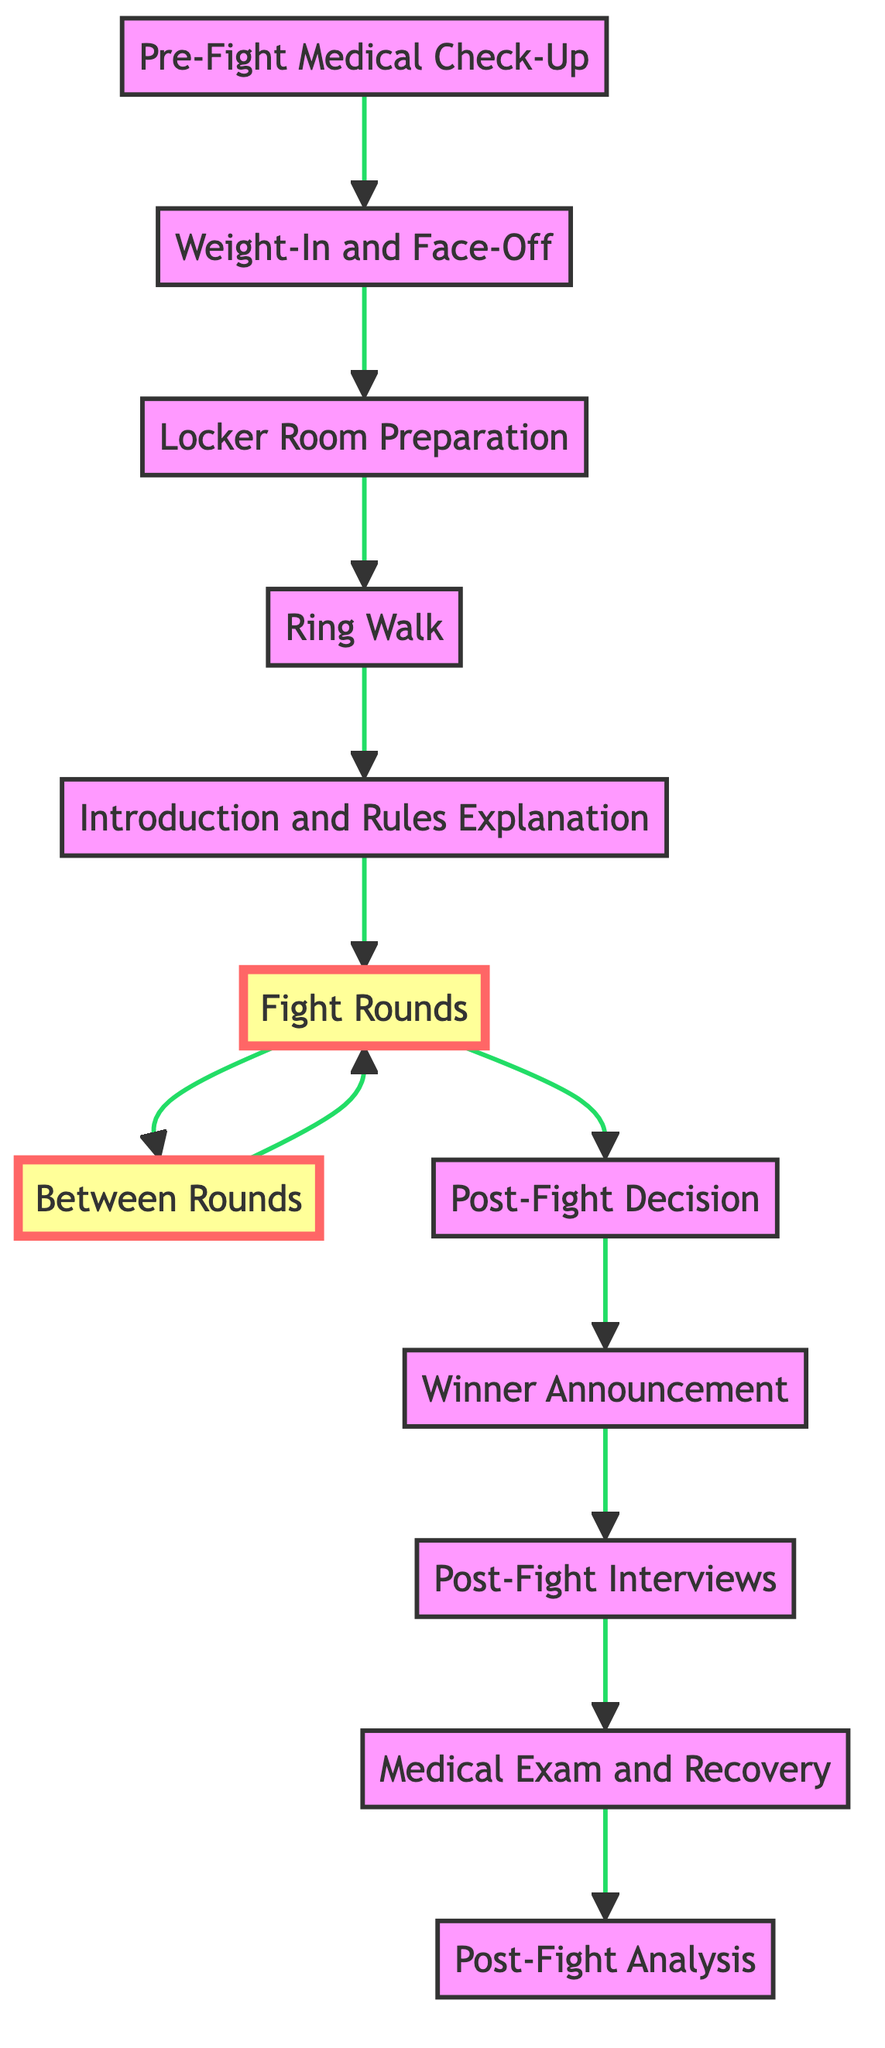What is the first step in the boxing match flow? The first step in the diagram is the "Pre-Fight Medical Check-Up," indicating that fighters start with medical examinations to ensure their fitness for the match.
Answer: Pre-Fight Medical Check-Up How many fight rounds are typically in a professional boxing match? According to the information in the diagram, a professional boxing match usually consists of 12 rounds, each lasting for 3 minutes.
Answer: 12 What happens after the "Fight Rounds"? After the "Fight Rounds," the next step described in the diagram is the "Post-Fight Decision," where judges assess the fight for a winner.
Answer: Post-Fight Decision What process occurs between each fight round? Between each fight round, fighters return to their corners for a one-minute rest where they receive advice and treatment from their trainers and cutmen, which is indicated as "Between Rounds."
Answer: Between Rounds Which step follows the "Winner Announcement"? The "Post-Fight Interviews" immediately follow the "Winner Announcement," indicating that fighters are interviewed regarding their performance after the match conclusion.
Answer: Post-Fight Interviews What is the final stage of the boxing match flow? The final stage listed in the boxing match flow is "Post-Fight Analysis," where analysts and commentators review the fight and discuss its key moments and strategies.
Answer: Post-Fight Analysis What happens directly after the "Introduction and Rules Explanation"? Right after the "Introduction and Rules Explanation," the match proceeds to the "Fight Rounds," marking the actual commencement of the boxing competition.
Answer: Fight Rounds Which step is highlighted in the diagram? The two steps highlighted in the diagram are "Fight Rounds" and "Between Rounds," indicating their significance in the boxing match flow.
Answer: Fight Rounds, Between Rounds How is the flow chart structured visually? The flow chart is a "Bottom to Top" style, meaning that the steps regarding the pre-fight actions are at the bottom, and the post-fight analysis is at the top, representing the progression of the event.
Answer: Bottom to Top 